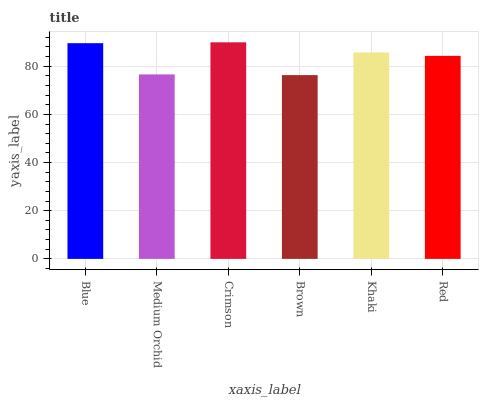Is Brown the minimum?
Answer yes or no. Yes. Is Crimson the maximum?
Answer yes or no. Yes. Is Medium Orchid the minimum?
Answer yes or no. No. Is Medium Orchid the maximum?
Answer yes or no. No. Is Blue greater than Medium Orchid?
Answer yes or no. Yes. Is Medium Orchid less than Blue?
Answer yes or no. Yes. Is Medium Orchid greater than Blue?
Answer yes or no. No. Is Blue less than Medium Orchid?
Answer yes or no. No. Is Khaki the high median?
Answer yes or no. Yes. Is Red the low median?
Answer yes or no. Yes. Is Blue the high median?
Answer yes or no. No. Is Medium Orchid the low median?
Answer yes or no. No. 